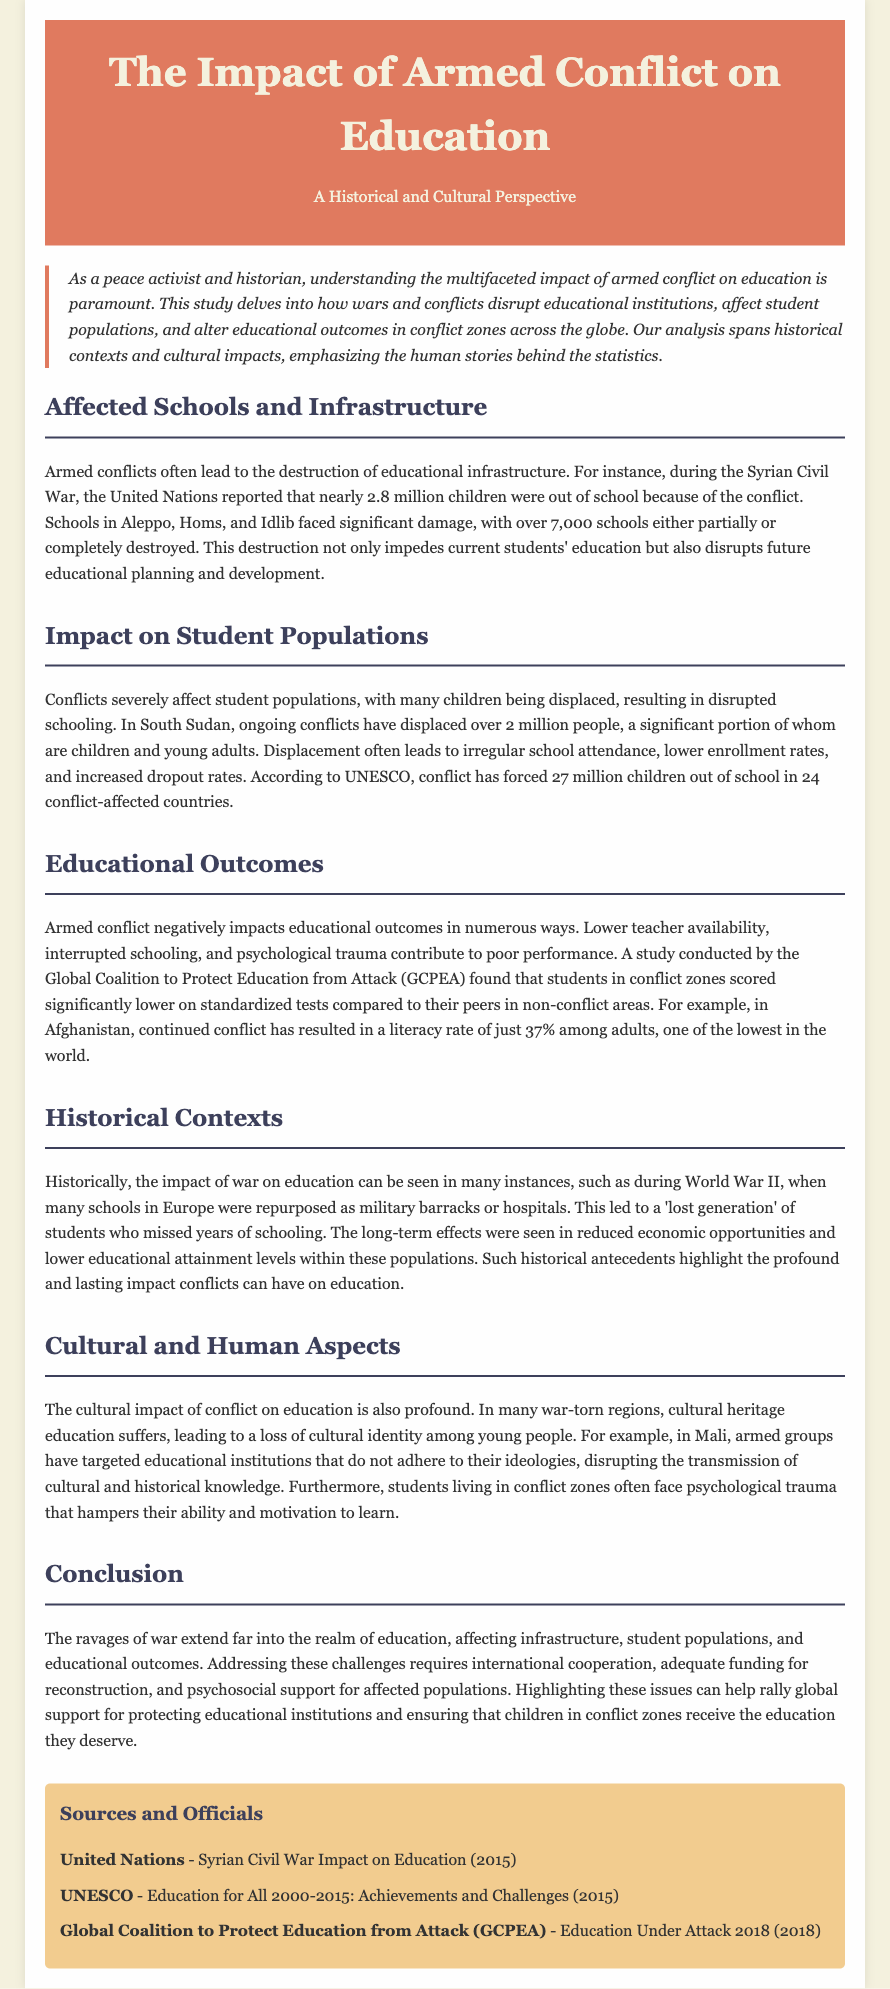What was the reported number of children out of school during the Syrian Civil War? The document states that nearly 2.8 million children were out of school because of the conflict.
Answer: 2.8 million Which three cities in Syria faced significant damage to schools? The study mentions Aleppo, Homs, and Idlib as cities that faced significant damage.
Answer: Aleppo, Homs, Idlib How many people, primarily children and young adults, were displaced in South Sudan due to conflicts? The document cites that over 2 million people were displaced, a significant portion being children and young adults.
Answer: Over 2 million What is the literacy rate among adults in Afghanistan mentioned in the document? The literacy rate mentioned in the study is just 37% among adults in Afghanistan.
Answer: 37% What organization conducted a study on students' performance in conflict zones? The study was conducted by the Global Coalition to Protect Education from Attack (GCPEA).
Answer: Global Coalition to Protect Education from Attack (GCPEA) What cultural impact does conflict have on education according to the document? The document explains that cultural heritage education suffers, leading to a loss of cultural identity among young people.
Answer: Loss of cultural identity What historical event led to many schools being repurposed as military barracks? The document references World War II as the historical event when many schools were repurposed.
Answer: World War II What is emphasized as a necessary aspect for addressing educational challenges in conflict zones? The document highlights that international cooperation and adequate funding for reconstruction are needed.
Answer: International cooperation 